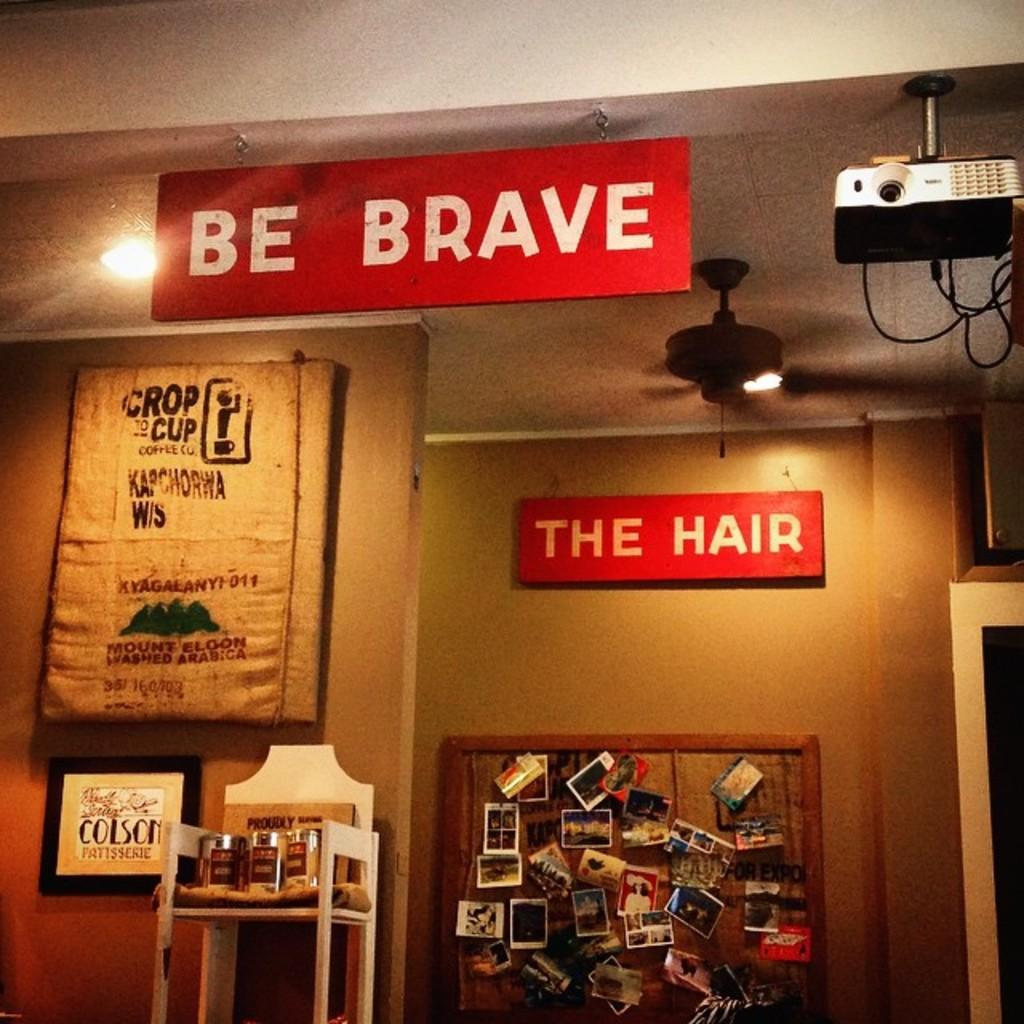<image>
Create a compact narrative representing the image presented. A red sign featuring the words "be brave" is displayed next to a projector. 